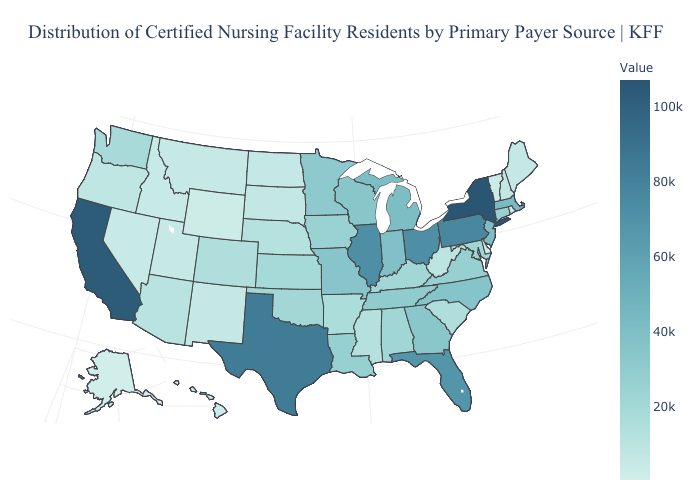Does California have the highest value in the West?
Give a very brief answer. Yes. Among the states that border Rhode Island , does Connecticut have the lowest value?
Be succinct. Yes. Among the states that border Montana , which have the lowest value?
Concise answer only. Wyoming. Among the states that border Washington , which have the lowest value?
Quick response, please. Idaho. 